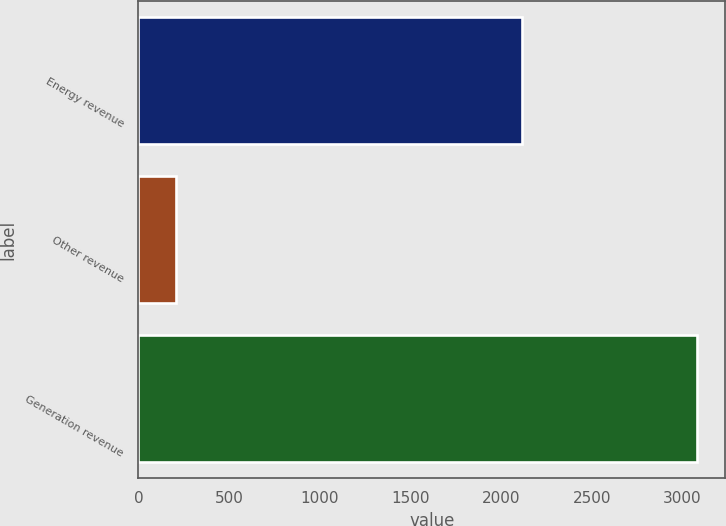Convert chart to OTSL. <chart><loc_0><loc_0><loc_500><loc_500><bar_chart><fcel>Energy revenue<fcel>Other revenue<fcel>Generation revenue<nl><fcel>2114<fcel>205<fcel>3081<nl></chart> 